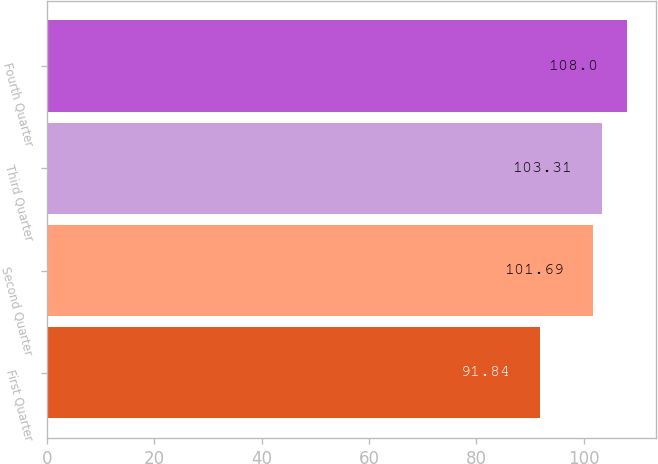Convert chart. <chart><loc_0><loc_0><loc_500><loc_500><bar_chart><fcel>First Quarter<fcel>Second Quarter<fcel>Third Quarter<fcel>Fourth Quarter<nl><fcel>91.84<fcel>101.69<fcel>103.31<fcel>108<nl></chart> 